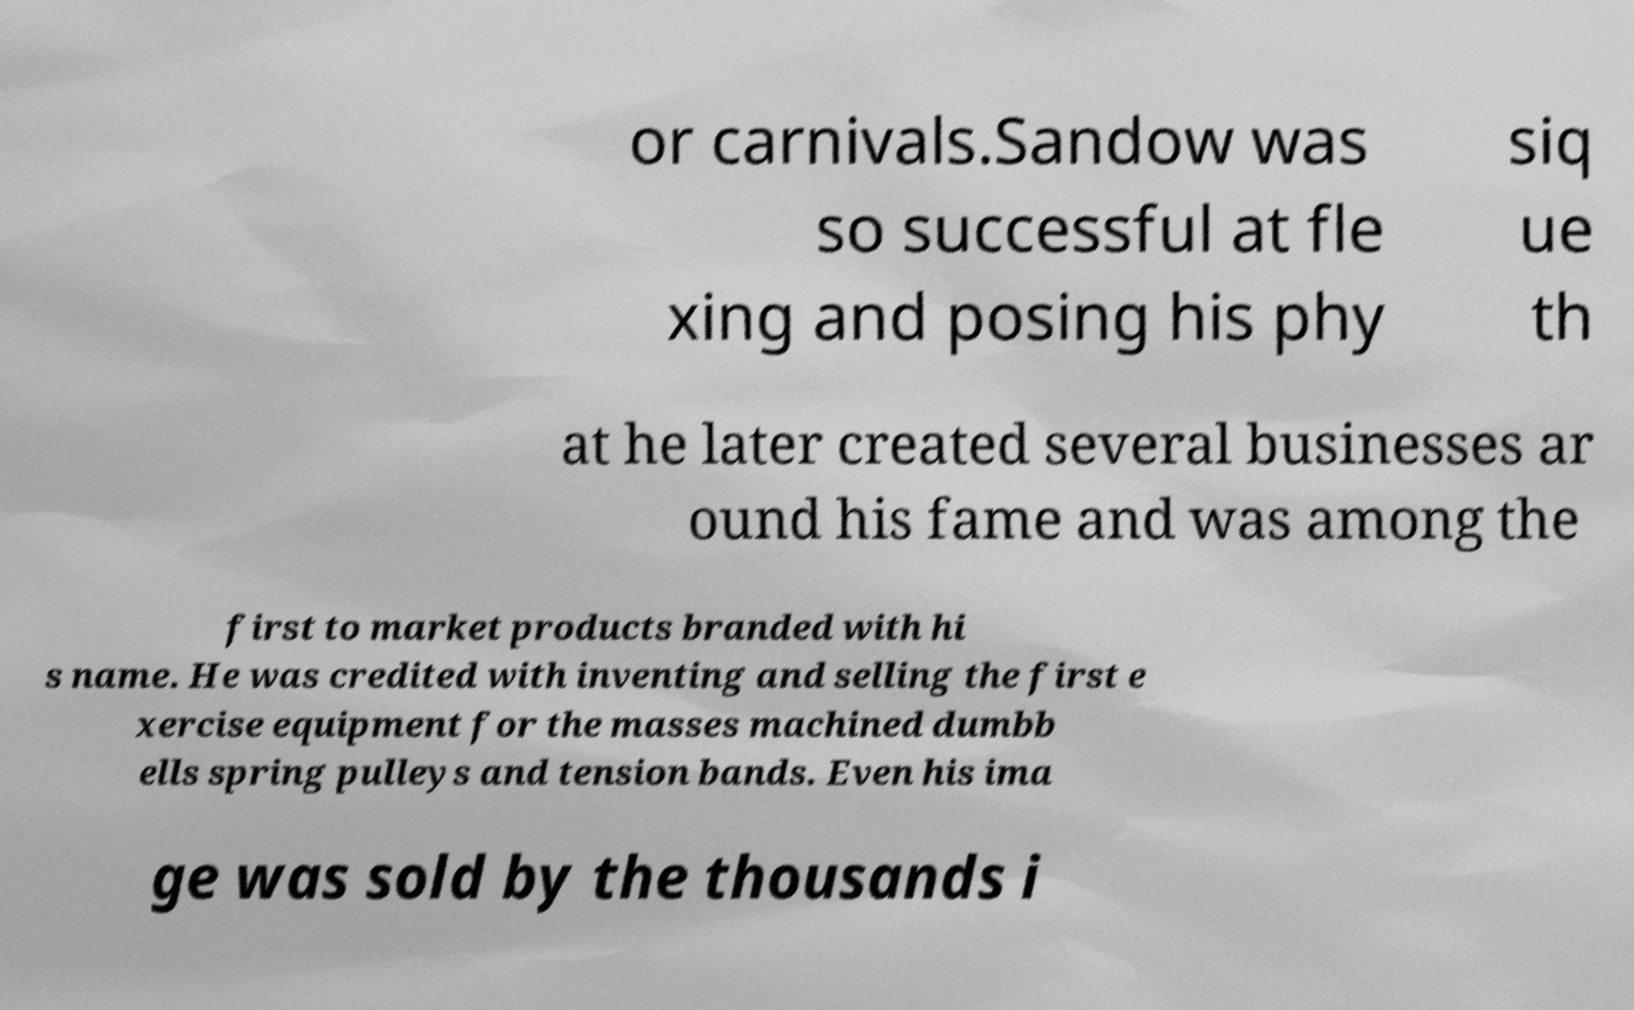Can you accurately transcribe the text from the provided image for me? or carnivals.Sandow was so successful at fle xing and posing his phy siq ue th at he later created several businesses ar ound his fame and was among the first to market products branded with hi s name. He was credited with inventing and selling the first e xercise equipment for the masses machined dumbb ells spring pulleys and tension bands. Even his ima ge was sold by the thousands i 